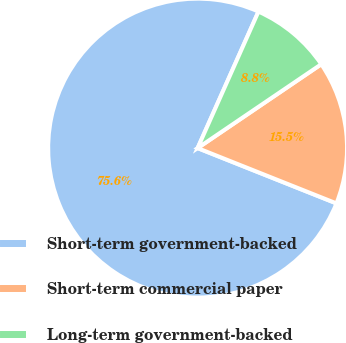Convert chart to OTSL. <chart><loc_0><loc_0><loc_500><loc_500><pie_chart><fcel>Short-term government-backed<fcel>Short-term commercial paper<fcel>Long-term government-backed<nl><fcel>75.64%<fcel>15.52%<fcel>8.84%<nl></chart> 